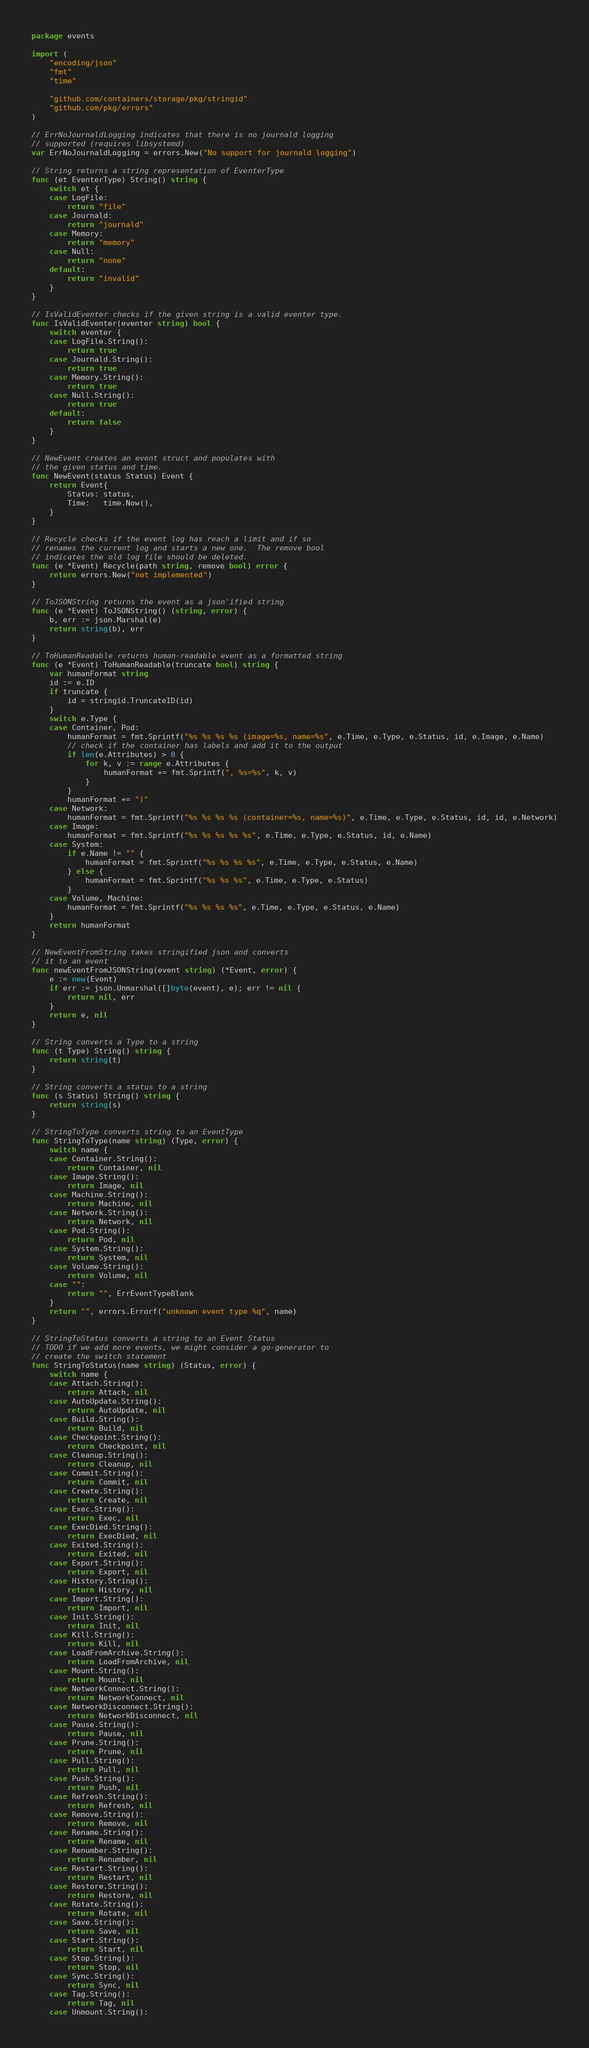<code> <loc_0><loc_0><loc_500><loc_500><_Go_>package events

import (
	"encoding/json"
	"fmt"
	"time"

	"github.com/containers/storage/pkg/stringid"
	"github.com/pkg/errors"
)

// ErrNoJournaldLogging indicates that there is no journald logging
// supported (requires libsystemd)
var ErrNoJournaldLogging = errors.New("No support for journald logging")

// String returns a string representation of EventerType
func (et EventerType) String() string {
	switch et {
	case LogFile:
		return "file"
	case Journald:
		return "journald"
	case Memory:
		return "memory"
	case Null:
		return "none"
	default:
		return "invalid"
	}
}

// IsValidEventer checks if the given string is a valid eventer type.
func IsValidEventer(eventer string) bool {
	switch eventer {
	case LogFile.String():
		return true
	case Journald.String():
		return true
	case Memory.String():
		return true
	case Null.String():
		return true
	default:
		return false
	}
}

// NewEvent creates an event struct and populates with
// the given status and time.
func NewEvent(status Status) Event {
	return Event{
		Status: status,
		Time:   time.Now(),
	}
}

// Recycle checks if the event log has reach a limit and if so
// renames the current log and starts a new one.  The remove bool
// indicates the old log file should be deleted.
func (e *Event) Recycle(path string, remove bool) error {
	return errors.New("not implemented")
}

// ToJSONString returns the event as a json'ified string
func (e *Event) ToJSONString() (string, error) {
	b, err := json.Marshal(e)
	return string(b), err
}

// ToHumanReadable returns human-readable event as a formatted string
func (e *Event) ToHumanReadable(truncate bool) string {
	var humanFormat string
	id := e.ID
	if truncate {
		id = stringid.TruncateID(id)
	}
	switch e.Type {
	case Container, Pod:
		humanFormat = fmt.Sprintf("%s %s %s %s (image=%s, name=%s", e.Time, e.Type, e.Status, id, e.Image, e.Name)
		// check if the container has labels and add it to the output
		if len(e.Attributes) > 0 {
			for k, v := range e.Attributes {
				humanFormat += fmt.Sprintf(", %s=%s", k, v)
			}
		}
		humanFormat += ")"
	case Network:
		humanFormat = fmt.Sprintf("%s %s %s %s (container=%s, name=%s)", e.Time, e.Type, e.Status, id, id, e.Network)
	case Image:
		humanFormat = fmt.Sprintf("%s %s %s %s %s", e.Time, e.Type, e.Status, id, e.Name)
	case System:
		if e.Name != "" {
			humanFormat = fmt.Sprintf("%s %s %s %s", e.Time, e.Type, e.Status, e.Name)
		} else {
			humanFormat = fmt.Sprintf("%s %s %s", e.Time, e.Type, e.Status)
		}
	case Volume, Machine:
		humanFormat = fmt.Sprintf("%s %s %s %s", e.Time, e.Type, e.Status, e.Name)
	}
	return humanFormat
}

// NewEventFromString takes stringified json and converts
// it to an event
func newEventFromJSONString(event string) (*Event, error) {
	e := new(Event)
	if err := json.Unmarshal([]byte(event), e); err != nil {
		return nil, err
	}
	return e, nil
}

// String converts a Type to a string
func (t Type) String() string {
	return string(t)
}

// String converts a status to a string
func (s Status) String() string {
	return string(s)
}

// StringToType converts string to an EventType
func StringToType(name string) (Type, error) {
	switch name {
	case Container.String():
		return Container, nil
	case Image.String():
		return Image, nil
	case Machine.String():
		return Machine, nil
	case Network.String():
		return Network, nil
	case Pod.String():
		return Pod, nil
	case System.String():
		return System, nil
	case Volume.String():
		return Volume, nil
	case "":
		return "", ErrEventTypeBlank
	}
	return "", errors.Errorf("unknown event type %q", name)
}

// StringToStatus converts a string to an Event Status
// TODO if we add more events, we might consider a go-generator to
// create the switch statement
func StringToStatus(name string) (Status, error) {
	switch name {
	case Attach.String():
		return Attach, nil
	case AutoUpdate.String():
		return AutoUpdate, nil
	case Build.String():
		return Build, nil
	case Checkpoint.String():
		return Checkpoint, nil
	case Cleanup.String():
		return Cleanup, nil
	case Commit.String():
		return Commit, nil
	case Create.String():
		return Create, nil
	case Exec.String():
		return Exec, nil
	case ExecDied.String():
		return ExecDied, nil
	case Exited.String():
		return Exited, nil
	case Export.String():
		return Export, nil
	case History.String():
		return History, nil
	case Import.String():
		return Import, nil
	case Init.String():
		return Init, nil
	case Kill.String():
		return Kill, nil
	case LoadFromArchive.String():
		return LoadFromArchive, nil
	case Mount.String():
		return Mount, nil
	case NetworkConnect.String():
		return NetworkConnect, nil
	case NetworkDisconnect.String():
		return NetworkDisconnect, nil
	case Pause.String():
		return Pause, nil
	case Prune.String():
		return Prune, nil
	case Pull.String():
		return Pull, nil
	case Push.String():
		return Push, nil
	case Refresh.String():
		return Refresh, nil
	case Remove.String():
		return Remove, nil
	case Rename.String():
		return Rename, nil
	case Renumber.String():
		return Renumber, nil
	case Restart.String():
		return Restart, nil
	case Restore.String():
		return Restore, nil
	case Rotate.String():
		return Rotate, nil
	case Save.String():
		return Save, nil
	case Start.String():
		return Start, nil
	case Stop.String():
		return Stop, nil
	case Sync.String():
		return Sync, nil
	case Tag.String():
		return Tag, nil
	case Unmount.String():</code> 